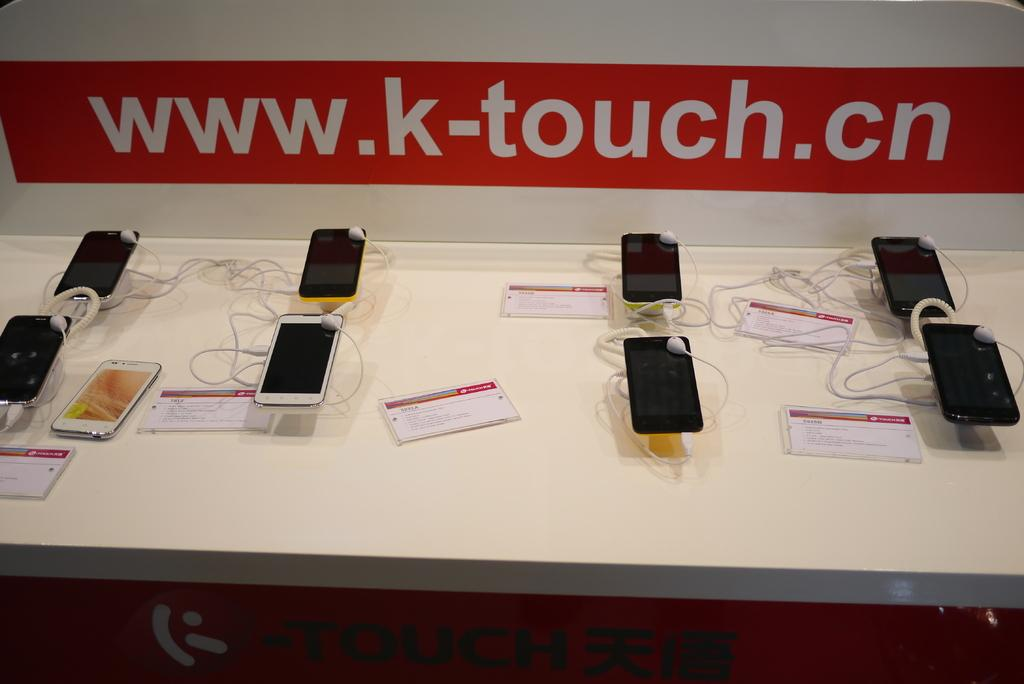<image>
Create a compact narrative representing the image presented. Multiple smart phones are on display under a banner that reads www.k-touch.cn. 